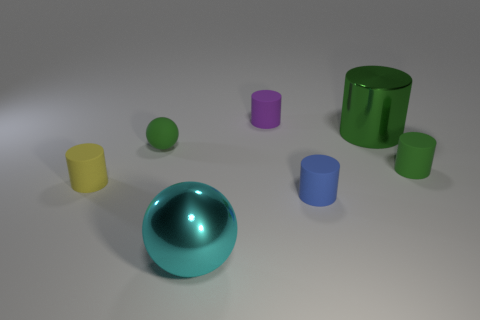How many other things are made of the same material as the cyan sphere?
Provide a short and direct response. 1. Does the large thing that is to the left of the tiny purple cylinder have the same shape as the small green matte object on the right side of the large cyan metal ball?
Give a very brief answer. No. The small matte cylinder behind the small rubber thing that is on the right side of the small cylinder in front of the yellow cylinder is what color?
Keep it short and to the point. Purple. What number of other objects are the same color as the big shiny cylinder?
Keep it short and to the point. 2. Are there fewer large cylinders than metallic objects?
Your answer should be very brief. Yes. The object that is both behind the cyan ball and in front of the yellow cylinder is what color?
Ensure brevity in your answer.  Blue. What material is the large green object that is the same shape as the blue matte object?
Keep it short and to the point. Metal. Is there anything else that has the same size as the metallic cylinder?
Offer a very short reply. Yes. Are there more tiny green matte spheres than red rubber spheres?
Provide a succinct answer. Yes. What size is the object that is both behind the green ball and on the left side of the metallic cylinder?
Provide a short and direct response. Small. 